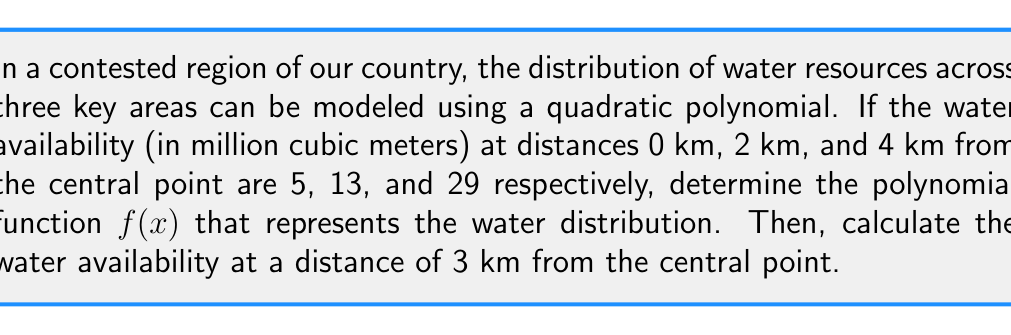Can you solve this math problem? Let's approach this step-by-step using polynomial interpolation:

1) We're looking for a quadratic function of the form $f(x) = ax^2 + bx + c$

2) We have three points: (0, 5), (2, 13), and (4, 29)

3) Substituting these into our function:
   $f(0) = a(0)^2 + b(0) + c = 5$
   $f(2) = a(2)^2 + b(2) + c = 13$
   $f(4) = a(4)^2 + b(4) + c = 29$

4) From the first equation: $c = 5$

5) Substituting this into the other two equations:
   $4a + 2b + 5 = 13$
   $16a + 4b + 5 = 29$

6) Simplifying:
   $4a + 2b = 8$  (Equation 1)
   $16a + 4b = 24$ (Equation 2)

7) Multiply Equation 1 by 2:
   $8a + 4b = 16$ (Equation 3)

8) Subtract Equation 3 from Equation 2:
   $8a = 8$
   $a = 1$

9) Substitute $a = 1$ into Equation 1:
   $4 + 2b = 8$
   $2b = 4$
   $b = 2$

10) Therefore, our function is: $f(x) = x^2 + 2x + 5$

11) To find the water availability at 3 km:
    $f(3) = 3^2 + 2(3) + 5 = 9 + 6 + 5 = 20$
Answer: $f(x) = x^2 + 2x + 5$; 20 million cubic meters at 3 km 